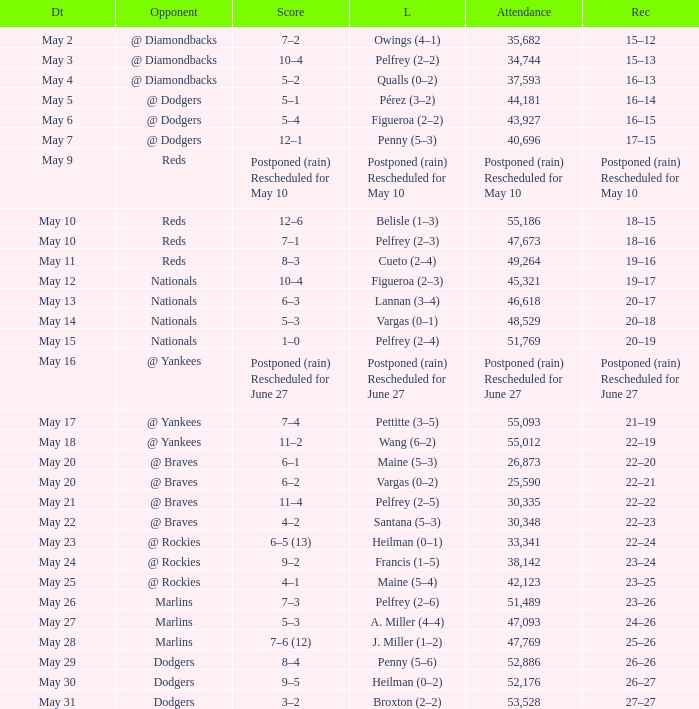Opponent of @ braves, and a Loss of pelfrey (2–5) had what score? 11–4. 